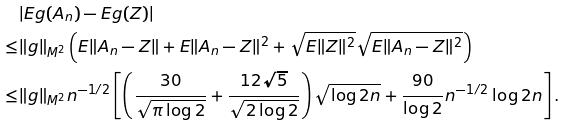Convert formula to latex. <formula><loc_0><loc_0><loc_500><loc_500>& | \mathbb { m } { E } g ( A _ { n } ) - \mathbb { m } { E } g ( Z ) | \\ \leq & \| g \| _ { M ^ { 2 } } \left ( \mathbb { m } { E } \| A _ { n } - Z \| + \mathbb { m } { E } \| A _ { n } - Z \| ^ { 2 } + \sqrt { \mathbb { m } { E } \| Z \| ^ { 2 } } \sqrt { \mathbb { m } { E } \| A _ { n } - Z \| ^ { 2 } } \right ) \\ \leq & \| g \| _ { M ^ { 2 } } n ^ { - 1 / 2 } \left [ \left ( \frac { 3 0 } { \sqrt { \pi \log 2 } } + \frac { 1 2 \sqrt { 5 } } { \sqrt { 2 \log 2 } } \right ) \sqrt { \log 2 n } + \frac { 9 0 } { \log 2 } n ^ { - 1 / 2 } \log 2 n \right ] \text {.}</formula> 